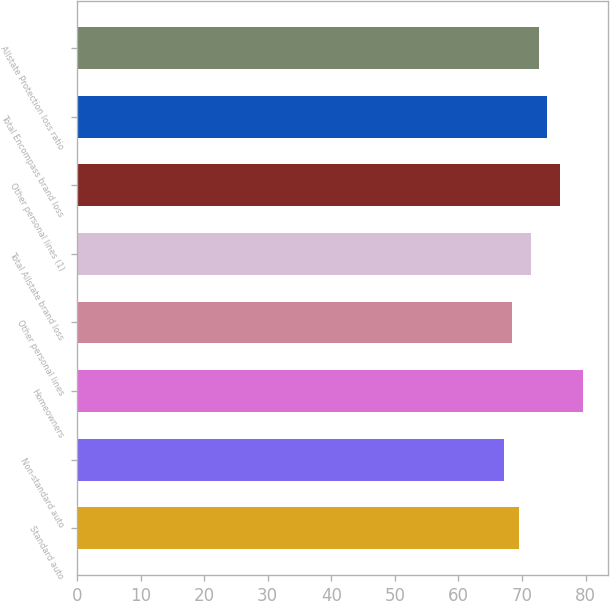<chart> <loc_0><loc_0><loc_500><loc_500><bar_chart><fcel>Standard auto<fcel>Non-standard auto<fcel>Homeowners<fcel>Other personal lines<fcel>Total Allstate brand loss<fcel>Other personal lines (1)<fcel>Total Encompass brand loss<fcel>Allstate Protection loss ratio<nl><fcel>69.6<fcel>67.1<fcel>79.6<fcel>68.35<fcel>71.4<fcel>75.9<fcel>73.9<fcel>72.65<nl></chart> 